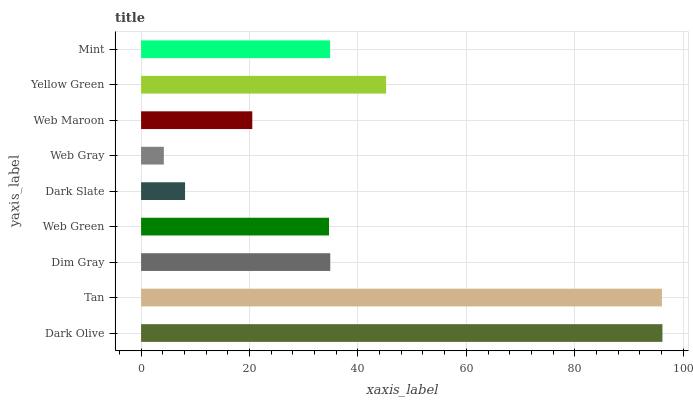Is Web Gray the minimum?
Answer yes or no. Yes. Is Dark Olive the maximum?
Answer yes or no. Yes. Is Tan the minimum?
Answer yes or no. No. Is Tan the maximum?
Answer yes or no. No. Is Dark Olive greater than Tan?
Answer yes or no. Yes. Is Tan less than Dark Olive?
Answer yes or no. Yes. Is Tan greater than Dark Olive?
Answer yes or no. No. Is Dark Olive less than Tan?
Answer yes or no. No. Is Mint the high median?
Answer yes or no. Yes. Is Mint the low median?
Answer yes or no. Yes. Is Yellow Green the high median?
Answer yes or no. No. Is Yellow Green the low median?
Answer yes or no. No. 